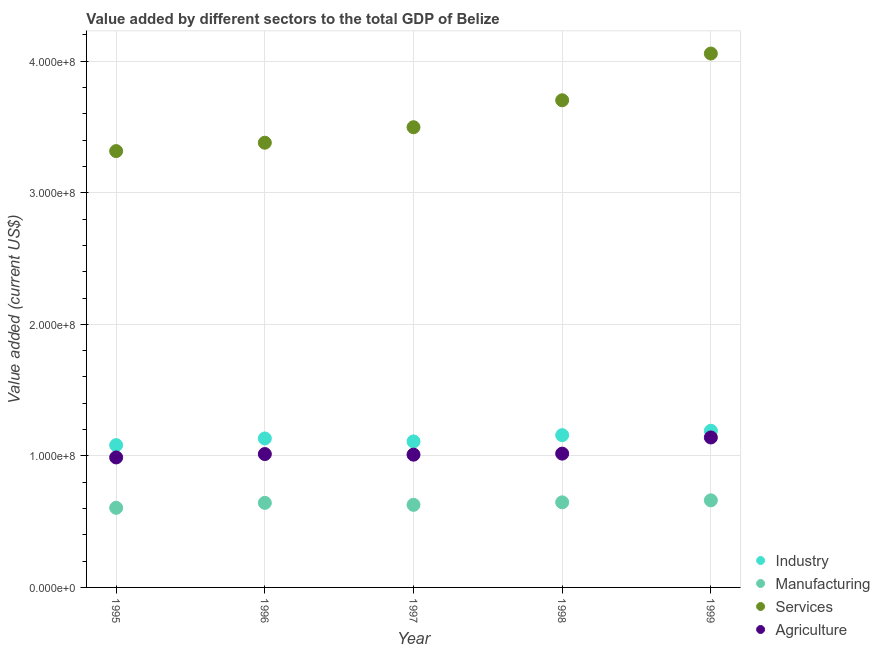How many different coloured dotlines are there?
Provide a short and direct response. 4. What is the value added by manufacturing sector in 1995?
Ensure brevity in your answer.  6.05e+07. Across all years, what is the maximum value added by industrial sector?
Provide a succinct answer. 1.19e+08. Across all years, what is the minimum value added by agricultural sector?
Give a very brief answer. 9.88e+07. In which year was the value added by agricultural sector maximum?
Your response must be concise. 1999. What is the total value added by agricultural sector in the graph?
Give a very brief answer. 5.17e+08. What is the difference between the value added by agricultural sector in 1997 and that in 1998?
Offer a very short reply. -7.87e+05. What is the difference between the value added by agricultural sector in 1997 and the value added by manufacturing sector in 1996?
Give a very brief answer. 3.66e+07. What is the average value added by industrial sector per year?
Make the answer very short. 1.13e+08. In the year 1997, what is the difference between the value added by manufacturing sector and value added by industrial sector?
Make the answer very short. -4.82e+07. In how many years, is the value added by services sector greater than 300000000 US$?
Keep it short and to the point. 5. What is the ratio of the value added by services sector in 1995 to that in 1999?
Provide a succinct answer. 0.82. What is the difference between the highest and the second highest value added by industrial sector?
Give a very brief answer. 3.32e+06. What is the difference between the highest and the lowest value added by industrial sector?
Your response must be concise. 1.09e+07. Is the sum of the value added by services sector in 1996 and 1998 greater than the maximum value added by agricultural sector across all years?
Provide a short and direct response. Yes. Does the value added by services sector monotonically increase over the years?
Make the answer very short. Yes. How many dotlines are there?
Your answer should be compact. 4. What is the difference between two consecutive major ticks on the Y-axis?
Offer a very short reply. 1.00e+08. Does the graph contain any zero values?
Your answer should be compact. No. Does the graph contain grids?
Keep it short and to the point. Yes. How many legend labels are there?
Offer a terse response. 4. What is the title of the graph?
Your answer should be very brief. Value added by different sectors to the total GDP of Belize. What is the label or title of the X-axis?
Give a very brief answer. Year. What is the label or title of the Y-axis?
Keep it short and to the point. Value added (current US$). What is the Value added (current US$) of Industry in 1995?
Ensure brevity in your answer.  1.08e+08. What is the Value added (current US$) in Manufacturing in 1995?
Make the answer very short. 6.05e+07. What is the Value added (current US$) of Services in 1995?
Provide a succinct answer. 3.32e+08. What is the Value added (current US$) of Agriculture in 1995?
Make the answer very short. 9.88e+07. What is the Value added (current US$) in Industry in 1996?
Your answer should be compact. 1.13e+08. What is the Value added (current US$) in Manufacturing in 1996?
Keep it short and to the point. 6.43e+07. What is the Value added (current US$) of Services in 1996?
Ensure brevity in your answer.  3.38e+08. What is the Value added (current US$) in Agriculture in 1996?
Keep it short and to the point. 1.01e+08. What is the Value added (current US$) of Industry in 1997?
Provide a short and direct response. 1.11e+08. What is the Value added (current US$) of Manufacturing in 1997?
Provide a short and direct response. 6.28e+07. What is the Value added (current US$) of Services in 1997?
Your response must be concise. 3.50e+08. What is the Value added (current US$) of Agriculture in 1997?
Keep it short and to the point. 1.01e+08. What is the Value added (current US$) of Industry in 1998?
Provide a short and direct response. 1.16e+08. What is the Value added (current US$) in Manufacturing in 1998?
Give a very brief answer. 6.47e+07. What is the Value added (current US$) in Services in 1998?
Keep it short and to the point. 3.70e+08. What is the Value added (current US$) of Agriculture in 1998?
Give a very brief answer. 1.02e+08. What is the Value added (current US$) in Industry in 1999?
Offer a terse response. 1.19e+08. What is the Value added (current US$) in Manufacturing in 1999?
Offer a very short reply. 6.62e+07. What is the Value added (current US$) of Services in 1999?
Provide a short and direct response. 4.06e+08. What is the Value added (current US$) in Agriculture in 1999?
Make the answer very short. 1.14e+08. Across all years, what is the maximum Value added (current US$) of Industry?
Ensure brevity in your answer.  1.19e+08. Across all years, what is the maximum Value added (current US$) in Manufacturing?
Provide a short and direct response. 6.62e+07. Across all years, what is the maximum Value added (current US$) in Services?
Offer a very short reply. 4.06e+08. Across all years, what is the maximum Value added (current US$) in Agriculture?
Keep it short and to the point. 1.14e+08. Across all years, what is the minimum Value added (current US$) of Industry?
Your answer should be very brief. 1.08e+08. Across all years, what is the minimum Value added (current US$) of Manufacturing?
Ensure brevity in your answer.  6.05e+07. Across all years, what is the minimum Value added (current US$) of Services?
Your response must be concise. 3.32e+08. Across all years, what is the minimum Value added (current US$) in Agriculture?
Offer a very short reply. 9.88e+07. What is the total Value added (current US$) of Industry in the graph?
Your answer should be compact. 5.67e+08. What is the total Value added (current US$) in Manufacturing in the graph?
Your answer should be very brief. 3.18e+08. What is the total Value added (current US$) in Services in the graph?
Keep it short and to the point. 1.80e+09. What is the total Value added (current US$) in Agriculture in the graph?
Offer a terse response. 5.17e+08. What is the difference between the Value added (current US$) of Industry in 1995 and that in 1996?
Keep it short and to the point. -5.08e+06. What is the difference between the Value added (current US$) of Manufacturing in 1995 and that in 1996?
Provide a succinct answer. -3.77e+06. What is the difference between the Value added (current US$) of Services in 1995 and that in 1996?
Give a very brief answer. -6.38e+06. What is the difference between the Value added (current US$) of Agriculture in 1995 and that in 1996?
Your answer should be compact. -2.58e+06. What is the difference between the Value added (current US$) of Industry in 1995 and that in 1997?
Your answer should be compact. -2.82e+06. What is the difference between the Value added (current US$) in Manufacturing in 1995 and that in 1997?
Provide a succinct answer. -2.25e+06. What is the difference between the Value added (current US$) in Services in 1995 and that in 1997?
Your response must be concise. -1.82e+07. What is the difference between the Value added (current US$) of Agriculture in 1995 and that in 1997?
Your answer should be very brief. -2.12e+06. What is the difference between the Value added (current US$) in Industry in 1995 and that in 1998?
Your answer should be compact. -7.58e+06. What is the difference between the Value added (current US$) in Manufacturing in 1995 and that in 1998?
Provide a succinct answer. -4.17e+06. What is the difference between the Value added (current US$) in Services in 1995 and that in 1998?
Offer a terse response. -3.87e+07. What is the difference between the Value added (current US$) in Agriculture in 1995 and that in 1998?
Your answer should be compact. -2.91e+06. What is the difference between the Value added (current US$) in Industry in 1995 and that in 1999?
Your answer should be very brief. -1.09e+07. What is the difference between the Value added (current US$) in Manufacturing in 1995 and that in 1999?
Your answer should be compact. -5.67e+06. What is the difference between the Value added (current US$) in Services in 1995 and that in 1999?
Provide a succinct answer. -7.42e+07. What is the difference between the Value added (current US$) of Agriculture in 1995 and that in 1999?
Ensure brevity in your answer.  -1.52e+07. What is the difference between the Value added (current US$) in Industry in 1996 and that in 1997?
Your answer should be compact. 2.26e+06. What is the difference between the Value added (current US$) in Manufacturing in 1996 and that in 1997?
Offer a very short reply. 1.52e+06. What is the difference between the Value added (current US$) of Services in 1996 and that in 1997?
Make the answer very short. -1.18e+07. What is the difference between the Value added (current US$) of Agriculture in 1996 and that in 1997?
Offer a terse response. 4.60e+05. What is the difference between the Value added (current US$) of Industry in 1996 and that in 1998?
Ensure brevity in your answer.  -2.50e+06. What is the difference between the Value added (current US$) of Manufacturing in 1996 and that in 1998?
Provide a short and direct response. -4.05e+05. What is the difference between the Value added (current US$) in Services in 1996 and that in 1998?
Your response must be concise. -3.23e+07. What is the difference between the Value added (current US$) in Agriculture in 1996 and that in 1998?
Provide a succinct answer. -3.28e+05. What is the difference between the Value added (current US$) in Industry in 1996 and that in 1999?
Ensure brevity in your answer.  -5.82e+06. What is the difference between the Value added (current US$) in Manufacturing in 1996 and that in 1999?
Keep it short and to the point. -1.90e+06. What is the difference between the Value added (current US$) in Services in 1996 and that in 1999?
Provide a short and direct response. -6.78e+07. What is the difference between the Value added (current US$) of Agriculture in 1996 and that in 1999?
Make the answer very short. -1.26e+07. What is the difference between the Value added (current US$) in Industry in 1997 and that in 1998?
Give a very brief answer. -4.76e+06. What is the difference between the Value added (current US$) of Manufacturing in 1997 and that in 1998?
Your answer should be compact. -1.92e+06. What is the difference between the Value added (current US$) in Services in 1997 and that in 1998?
Offer a very short reply. -2.05e+07. What is the difference between the Value added (current US$) of Agriculture in 1997 and that in 1998?
Ensure brevity in your answer.  -7.87e+05. What is the difference between the Value added (current US$) in Industry in 1997 and that in 1999?
Offer a very short reply. -8.08e+06. What is the difference between the Value added (current US$) in Manufacturing in 1997 and that in 1999?
Offer a very short reply. -3.42e+06. What is the difference between the Value added (current US$) of Services in 1997 and that in 1999?
Your answer should be compact. -5.60e+07. What is the difference between the Value added (current US$) of Agriculture in 1997 and that in 1999?
Your answer should be very brief. -1.31e+07. What is the difference between the Value added (current US$) of Industry in 1998 and that in 1999?
Your answer should be compact. -3.32e+06. What is the difference between the Value added (current US$) in Manufacturing in 1998 and that in 1999?
Make the answer very short. -1.50e+06. What is the difference between the Value added (current US$) in Services in 1998 and that in 1999?
Ensure brevity in your answer.  -3.55e+07. What is the difference between the Value added (current US$) of Agriculture in 1998 and that in 1999?
Offer a very short reply. -1.23e+07. What is the difference between the Value added (current US$) of Industry in 1995 and the Value added (current US$) of Manufacturing in 1996?
Your response must be concise. 4.39e+07. What is the difference between the Value added (current US$) of Industry in 1995 and the Value added (current US$) of Services in 1996?
Ensure brevity in your answer.  -2.30e+08. What is the difference between the Value added (current US$) in Industry in 1995 and the Value added (current US$) in Agriculture in 1996?
Your response must be concise. 6.78e+06. What is the difference between the Value added (current US$) of Manufacturing in 1995 and the Value added (current US$) of Services in 1996?
Make the answer very short. -2.78e+08. What is the difference between the Value added (current US$) in Manufacturing in 1995 and the Value added (current US$) in Agriculture in 1996?
Provide a succinct answer. -4.09e+07. What is the difference between the Value added (current US$) in Services in 1995 and the Value added (current US$) in Agriculture in 1996?
Keep it short and to the point. 2.30e+08. What is the difference between the Value added (current US$) of Industry in 1995 and the Value added (current US$) of Manufacturing in 1997?
Offer a very short reply. 4.54e+07. What is the difference between the Value added (current US$) of Industry in 1995 and the Value added (current US$) of Services in 1997?
Your answer should be very brief. -2.42e+08. What is the difference between the Value added (current US$) in Industry in 1995 and the Value added (current US$) in Agriculture in 1997?
Keep it short and to the point. 7.24e+06. What is the difference between the Value added (current US$) of Manufacturing in 1995 and the Value added (current US$) of Services in 1997?
Your answer should be very brief. -2.89e+08. What is the difference between the Value added (current US$) in Manufacturing in 1995 and the Value added (current US$) in Agriculture in 1997?
Your answer should be very brief. -4.04e+07. What is the difference between the Value added (current US$) in Services in 1995 and the Value added (current US$) in Agriculture in 1997?
Provide a short and direct response. 2.31e+08. What is the difference between the Value added (current US$) of Industry in 1995 and the Value added (current US$) of Manufacturing in 1998?
Your answer should be compact. 4.35e+07. What is the difference between the Value added (current US$) of Industry in 1995 and the Value added (current US$) of Services in 1998?
Ensure brevity in your answer.  -2.62e+08. What is the difference between the Value added (current US$) in Industry in 1995 and the Value added (current US$) in Agriculture in 1998?
Offer a terse response. 6.46e+06. What is the difference between the Value added (current US$) of Manufacturing in 1995 and the Value added (current US$) of Services in 1998?
Your response must be concise. -3.10e+08. What is the difference between the Value added (current US$) in Manufacturing in 1995 and the Value added (current US$) in Agriculture in 1998?
Offer a very short reply. -4.12e+07. What is the difference between the Value added (current US$) of Services in 1995 and the Value added (current US$) of Agriculture in 1998?
Offer a very short reply. 2.30e+08. What is the difference between the Value added (current US$) in Industry in 1995 and the Value added (current US$) in Manufacturing in 1999?
Make the answer very short. 4.20e+07. What is the difference between the Value added (current US$) in Industry in 1995 and the Value added (current US$) in Services in 1999?
Offer a terse response. -2.98e+08. What is the difference between the Value added (current US$) in Industry in 1995 and the Value added (current US$) in Agriculture in 1999?
Give a very brief answer. -5.82e+06. What is the difference between the Value added (current US$) of Manufacturing in 1995 and the Value added (current US$) of Services in 1999?
Give a very brief answer. -3.45e+08. What is the difference between the Value added (current US$) in Manufacturing in 1995 and the Value added (current US$) in Agriculture in 1999?
Offer a terse response. -5.35e+07. What is the difference between the Value added (current US$) in Services in 1995 and the Value added (current US$) in Agriculture in 1999?
Make the answer very short. 2.18e+08. What is the difference between the Value added (current US$) in Industry in 1996 and the Value added (current US$) in Manufacturing in 1997?
Ensure brevity in your answer.  5.05e+07. What is the difference between the Value added (current US$) in Industry in 1996 and the Value added (current US$) in Services in 1997?
Offer a terse response. -2.37e+08. What is the difference between the Value added (current US$) of Industry in 1996 and the Value added (current US$) of Agriculture in 1997?
Provide a succinct answer. 1.23e+07. What is the difference between the Value added (current US$) of Manufacturing in 1996 and the Value added (current US$) of Services in 1997?
Your response must be concise. -2.86e+08. What is the difference between the Value added (current US$) of Manufacturing in 1996 and the Value added (current US$) of Agriculture in 1997?
Offer a very short reply. -3.66e+07. What is the difference between the Value added (current US$) of Services in 1996 and the Value added (current US$) of Agriculture in 1997?
Give a very brief answer. 2.37e+08. What is the difference between the Value added (current US$) in Industry in 1996 and the Value added (current US$) in Manufacturing in 1998?
Offer a terse response. 4.86e+07. What is the difference between the Value added (current US$) of Industry in 1996 and the Value added (current US$) of Services in 1998?
Your answer should be compact. -2.57e+08. What is the difference between the Value added (current US$) in Industry in 1996 and the Value added (current US$) in Agriculture in 1998?
Make the answer very short. 1.15e+07. What is the difference between the Value added (current US$) of Manufacturing in 1996 and the Value added (current US$) of Services in 1998?
Your answer should be compact. -3.06e+08. What is the difference between the Value added (current US$) of Manufacturing in 1996 and the Value added (current US$) of Agriculture in 1998?
Keep it short and to the point. -3.74e+07. What is the difference between the Value added (current US$) of Services in 1996 and the Value added (current US$) of Agriculture in 1998?
Make the answer very short. 2.36e+08. What is the difference between the Value added (current US$) of Industry in 1996 and the Value added (current US$) of Manufacturing in 1999?
Provide a succinct answer. 4.71e+07. What is the difference between the Value added (current US$) in Industry in 1996 and the Value added (current US$) in Services in 1999?
Your response must be concise. -2.93e+08. What is the difference between the Value added (current US$) of Industry in 1996 and the Value added (current US$) of Agriculture in 1999?
Your response must be concise. -7.42e+05. What is the difference between the Value added (current US$) in Manufacturing in 1996 and the Value added (current US$) in Services in 1999?
Your answer should be compact. -3.42e+08. What is the difference between the Value added (current US$) of Manufacturing in 1996 and the Value added (current US$) of Agriculture in 1999?
Make the answer very short. -4.97e+07. What is the difference between the Value added (current US$) in Services in 1996 and the Value added (current US$) in Agriculture in 1999?
Offer a very short reply. 2.24e+08. What is the difference between the Value added (current US$) in Industry in 1997 and the Value added (current US$) in Manufacturing in 1998?
Provide a short and direct response. 4.63e+07. What is the difference between the Value added (current US$) of Industry in 1997 and the Value added (current US$) of Services in 1998?
Ensure brevity in your answer.  -2.59e+08. What is the difference between the Value added (current US$) in Industry in 1997 and the Value added (current US$) in Agriculture in 1998?
Your response must be concise. 9.28e+06. What is the difference between the Value added (current US$) of Manufacturing in 1997 and the Value added (current US$) of Services in 1998?
Offer a terse response. -3.08e+08. What is the difference between the Value added (current US$) of Manufacturing in 1997 and the Value added (current US$) of Agriculture in 1998?
Offer a terse response. -3.89e+07. What is the difference between the Value added (current US$) of Services in 1997 and the Value added (current US$) of Agriculture in 1998?
Offer a very short reply. 2.48e+08. What is the difference between the Value added (current US$) of Industry in 1997 and the Value added (current US$) of Manufacturing in 1999?
Your response must be concise. 4.48e+07. What is the difference between the Value added (current US$) of Industry in 1997 and the Value added (current US$) of Services in 1999?
Provide a short and direct response. -2.95e+08. What is the difference between the Value added (current US$) in Industry in 1997 and the Value added (current US$) in Agriculture in 1999?
Provide a short and direct response. -3.00e+06. What is the difference between the Value added (current US$) of Manufacturing in 1997 and the Value added (current US$) of Services in 1999?
Provide a short and direct response. -3.43e+08. What is the difference between the Value added (current US$) of Manufacturing in 1997 and the Value added (current US$) of Agriculture in 1999?
Keep it short and to the point. -5.12e+07. What is the difference between the Value added (current US$) in Services in 1997 and the Value added (current US$) in Agriculture in 1999?
Ensure brevity in your answer.  2.36e+08. What is the difference between the Value added (current US$) of Industry in 1998 and the Value added (current US$) of Manufacturing in 1999?
Provide a short and direct response. 4.96e+07. What is the difference between the Value added (current US$) in Industry in 1998 and the Value added (current US$) in Services in 1999?
Ensure brevity in your answer.  -2.90e+08. What is the difference between the Value added (current US$) in Industry in 1998 and the Value added (current US$) in Agriculture in 1999?
Offer a very short reply. 1.76e+06. What is the difference between the Value added (current US$) in Manufacturing in 1998 and the Value added (current US$) in Services in 1999?
Keep it short and to the point. -3.41e+08. What is the difference between the Value added (current US$) of Manufacturing in 1998 and the Value added (current US$) of Agriculture in 1999?
Keep it short and to the point. -4.93e+07. What is the difference between the Value added (current US$) of Services in 1998 and the Value added (current US$) of Agriculture in 1999?
Your answer should be very brief. 2.56e+08. What is the average Value added (current US$) of Industry per year?
Provide a succinct answer. 1.13e+08. What is the average Value added (current US$) in Manufacturing per year?
Ensure brevity in your answer.  6.37e+07. What is the average Value added (current US$) in Services per year?
Provide a short and direct response. 3.59e+08. What is the average Value added (current US$) of Agriculture per year?
Your answer should be compact. 1.03e+08. In the year 1995, what is the difference between the Value added (current US$) in Industry and Value added (current US$) in Manufacturing?
Your answer should be compact. 4.76e+07. In the year 1995, what is the difference between the Value added (current US$) in Industry and Value added (current US$) in Services?
Make the answer very short. -2.24e+08. In the year 1995, what is the difference between the Value added (current US$) in Industry and Value added (current US$) in Agriculture?
Ensure brevity in your answer.  9.36e+06. In the year 1995, what is the difference between the Value added (current US$) in Manufacturing and Value added (current US$) in Services?
Your answer should be very brief. -2.71e+08. In the year 1995, what is the difference between the Value added (current US$) in Manufacturing and Value added (current US$) in Agriculture?
Give a very brief answer. -3.83e+07. In the year 1995, what is the difference between the Value added (current US$) of Services and Value added (current US$) of Agriculture?
Keep it short and to the point. 2.33e+08. In the year 1996, what is the difference between the Value added (current US$) of Industry and Value added (current US$) of Manufacturing?
Offer a terse response. 4.90e+07. In the year 1996, what is the difference between the Value added (current US$) in Industry and Value added (current US$) in Services?
Make the answer very short. -2.25e+08. In the year 1996, what is the difference between the Value added (current US$) of Industry and Value added (current US$) of Agriculture?
Ensure brevity in your answer.  1.19e+07. In the year 1996, what is the difference between the Value added (current US$) of Manufacturing and Value added (current US$) of Services?
Offer a very short reply. -2.74e+08. In the year 1996, what is the difference between the Value added (current US$) in Manufacturing and Value added (current US$) in Agriculture?
Your answer should be compact. -3.71e+07. In the year 1996, what is the difference between the Value added (current US$) of Services and Value added (current US$) of Agriculture?
Provide a succinct answer. 2.37e+08. In the year 1997, what is the difference between the Value added (current US$) of Industry and Value added (current US$) of Manufacturing?
Your response must be concise. 4.82e+07. In the year 1997, what is the difference between the Value added (current US$) in Industry and Value added (current US$) in Services?
Provide a succinct answer. -2.39e+08. In the year 1997, what is the difference between the Value added (current US$) in Industry and Value added (current US$) in Agriculture?
Your answer should be compact. 1.01e+07. In the year 1997, what is the difference between the Value added (current US$) of Manufacturing and Value added (current US$) of Services?
Make the answer very short. -2.87e+08. In the year 1997, what is the difference between the Value added (current US$) in Manufacturing and Value added (current US$) in Agriculture?
Ensure brevity in your answer.  -3.82e+07. In the year 1997, what is the difference between the Value added (current US$) in Services and Value added (current US$) in Agriculture?
Give a very brief answer. 2.49e+08. In the year 1998, what is the difference between the Value added (current US$) of Industry and Value added (current US$) of Manufacturing?
Offer a very short reply. 5.11e+07. In the year 1998, what is the difference between the Value added (current US$) of Industry and Value added (current US$) of Services?
Provide a short and direct response. -2.55e+08. In the year 1998, what is the difference between the Value added (current US$) of Industry and Value added (current US$) of Agriculture?
Offer a terse response. 1.40e+07. In the year 1998, what is the difference between the Value added (current US$) of Manufacturing and Value added (current US$) of Services?
Your answer should be compact. -3.06e+08. In the year 1998, what is the difference between the Value added (current US$) of Manufacturing and Value added (current US$) of Agriculture?
Give a very brief answer. -3.70e+07. In the year 1998, what is the difference between the Value added (current US$) of Services and Value added (current US$) of Agriculture?
Offer a very short reply. 2.69e+08. In the year 1999, what is the difference between the Value added (current US$) in Industry and Value added (current US$) in Manufacturing?
Keep it short and to the point. 5.29e+07. In the year 1999, what is the difference between the Value added (current US$) of Industry and Value added (current US$) of Services?
Provide a short and direct response. -2.87e+08. In the year 1999, what is the difference between the Value added (current US$) of Industry and Value added (current US$) of Agriculture?
Give a very brief answer. 5.08e+06. In the year 1999, what is the difference between the Value added (current US$) in Manufacturing and Value added (current US$) in Services?
Your answer should be very brief. -3.40e+08. In the year 1999, what is the difference between the Value added (current US$) of Manufacturing and Value added (current US$) of Agriculture?
Your answer should be compact. -4.78e+07. In the year 1999, what is the difference between the Value added (current US$) in Services and Value added (current US$) in Agriculture?
Your response must be concise. 2.92e+08. What is the ratio of the Value added (current US$) in Industry in 1995 to that in 1996?
Give a very brief answer. 0.96. What is the ratio of the Value added (current US$) in Manufacturing in 1995 to that in 1996?
Keep it short and to the point. 0.94. What is the ratio of the Value added (current US$) in Services in 1995 to that in 1996?
Make the answer very short. 0.98. What is the ratio of the Value added (current US$) in Agriculture in 1995 to that in 1996?
Ensure brevity in your answer.  0.97. What is the ratio of the Value added (current US$) in Industry in 1995 to that in 1997?
Offer a terse response. 0.97. What is the ratio of the Value added (current US$) in Manufacturing in 1995 to that in 1997?
Your answer should be very brief. 0.96. What is the ratio of the Value added (current US$) of Services in 1995 to that in 1997?
Your answer should be compact. 0.95. What is the ratio of the Value added (current US$) of Agriculture in 1995 to that in 1997?
Ensure brevity in your answer.  0.98. What is the ratio of the Value added (current US$) of Industry in 1995 to that in 1998?
Make the answer very short. 0.93. What is the ratio of the Value added (current US$) of Manufacturing in 1995 to that in 1998?
Keep it short and to the point. 0.94. What is the ratio of the Value added (current US$) of Services in 1995 to that in 1998?
Offer a terse response. 0.9. What is the ratio of the Value added (current US$) in Agriculture in 1995 to that in 1998?
Offer a very short reply. 0.97. What is the ratio of the Value added (current US$) of Industry in 1995 to that in 1999?
Provide a short and direct response. 0.91. What is the ratio of the Value added (current US$) of Manufacturing in 1995 to that in 1999?
Your response must be concise. 0.91. What is the ratio of the Value added (current US$) of Services in 1995 to that in 1999?
Your response must be concise. 0.82. What is the ratio of the Value added (current US$) in Agriculture in 1995 to that in 1999?
Offer a very short reply. 0.87. What is the ratio of the Value added (current US$) in Industry in 1996 to that in 1997?
Give a very brief answer. 1.02. What is the ratio of the Value added (current US$) of Manufacturing in 1996 to that in 1997?
Your answer should be compact. 1.02. What is the ratio of the Value added (current US$) in Services in 1996 to that in 1997?
Keep it short and to the point. 0.97. What is the ratio of the Value added (current US$) of Agriculture in 1996 to that in 1997?
Your answer should be very brief. 1. What is the ratio of the Value added (current US$) of Industry in 1996 to that in 1998?
Your response must be concise. 0.98. What is the ratio of the Value added (current US$) of Services in 1996 to that in 1998?
Your answer should be compact. 0.91. What is the ratio of the Value added (current US$) in Agriculture in 1996 to that in 1998?
Your answer should be compact. 1. What is the ratio of the Value added (current US$) of Industry in 1996 to that in 1999?
Your answer should be very brief. 0.95. What is the ratio of the Value added (current US$) of Manufacturing in 1996 to that in 1999?
Provide a short and direct response. 0.97. What is the ratio of the Value added (current US$) in Services in 1996 to that in 1999?
Offer a very short reply. 0.83. What is the ratio of the Value added (current US$) in Agriculture in 1996 to that in 1999?
Ensure brevity in your answer.  0.89. What is the ratio of the Value added (current US$) of Industry in 1997 to that in 1998?
Keep it short and to the point. 0.96. What is the ratio of the Value added (current US$) in Manufacturing in 1997 to that in 1998?
Keep it short and to the point. 0.97. What is the ratio of the Value added (current US$) in Services in 1997 to that in 1998?
Provide a short and direct response. 0.94. What is the ratio of the Value added (current US$) in Agriculture in 1997 to that in 1998?
Provide a succinct answer. 0.99. What is the ratio of the Value added (current US$) of Industry in 1997 to that in 1999?
Your answer should be compact. 0.93. What is the ratio of the Value added (current US$) in Manufacturing in 1997 to that in 1999?
Give a very brief answer. 0.95. What is the ratio of the Value added (current US$) of Services in 1997 to that in 1999?
Offer a terse response. 0.86. What is the ratio of the Value added (current US$) of Agriculture in 1997 to that in 1999?
Offer a very short reply. 0.89. What is the ratio of the Value added (current US$) in Industry in 1998 to that in 1999?
Your answer should be compact. 0.97. What is the ratio of the Value added (current US$) of Manufacturing in 1998 to that in 1999?
Your response must be concise. 0.98. What is the ratio of the Value added (current US$) in Services in 1998 to that in 1999?
Ensure brevity in your answer.  0.91. What is the ratio of the Value added (current US$) in Agriculture in 1998 to that in 1999?
Offer a terse response. 0.89. What is the difference between the highest and the second highest Value added (current US$) of Industry?
Offer a terse response. 3.32e+06. What is the difference between the highest and the second highest Value added (current US$) of Manufacturing?
Offer a very short reply. 1.50e+06. What is the difference between the highest and the second highest Value added (current US$) of Services?
Ensure brevity in your answer.  3.55e+07. What is the difference between the highest and the second highest Value added (current US$) in Agriculture?
Provide a succinct answer. 1.23e+07. What is the difference between the highest and the lowest Value added (current US$) of Industry?
Give a very brief answer. 1.09e+07. What is the difference between the highest and the lowest Value added (current US$) in Manufacturing?
Your answer should be very brief. 5.67e+06. What is the difference between the highest and the lowest Value added (current US$) of Services?
Provide a succinct answer. 7.42e+07. What is the difference between the highest and the lowest Value added (current US$) of Agriculture?
Ensure brevity in your answer.  1.52e+07. 